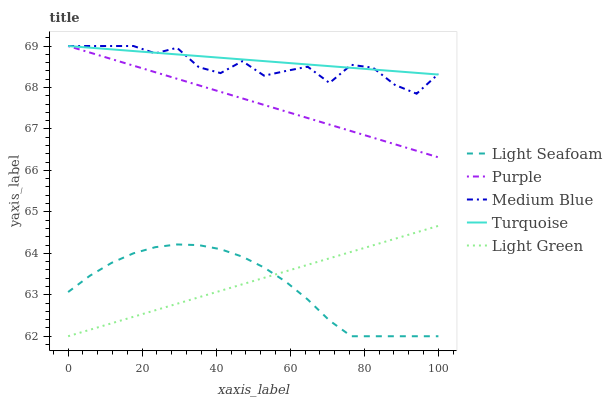Does Light Seafoam have the minimum area under the curve?
Answer yes or no. Yes. Does Turquoise have the maximum area under the curve?
Answer yes or no. Yes. Does Turquoise have the minimum area under the curve?
Answer yes or no. No. Does Light Seafoam have the maximum area under the curve?
Answer yes or no. No. Is Purple the smoothest?
Answer yes or no. Yes. Is Medium Blue the roughest?
Answer yes or no. Yes. Is Turquoise the smoothest?
Answer yes or no. No. Is Turquoise the roughest?
Answer yes or no. No. Does Light Seafoam have the lowest value?
Answer yes or no. Yes. Does Turquoise have the lowest value?
Answer yes or no. No. Does Medium Blue have the highest value?
Answer yes or no. Yes. Does Light Seafoam have the highest value?
Answer yes or no. No. Is Light Green less than Medium Blue?
Answer yes or no. Yes. Is Purple greater than Light Seafoam?
Answer yes or no. Yes. Does Purple intersect Turquoise?
Answer yes or no. Yes. Is Purple less than Turquoise?
Answer yes or no. No. Is Purple greater than Turquoise?
Answer yes or no. No. Does Light Green intersect Medium Blue?
Answer yes or no. No. 